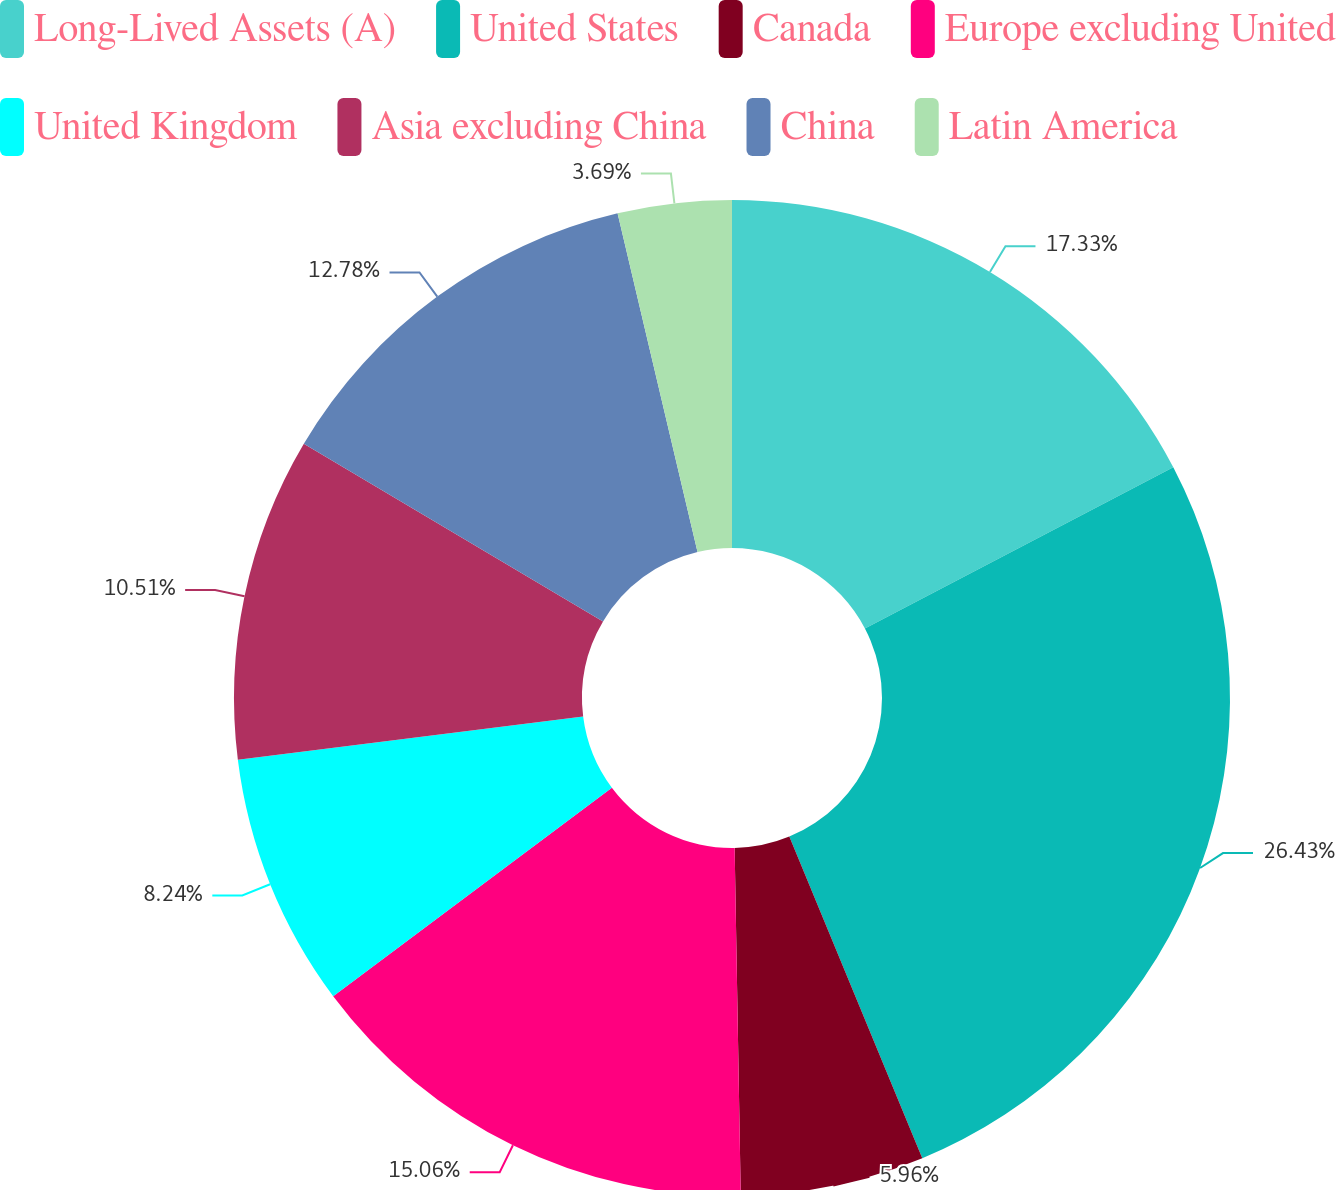<chart> <loc_0><loc_0><loc_500><loc_500><pie_chart><fcel>Long-Lived Assets (A)<fcel>United States<fcel>Canada<fcel>Europe excluding United<fcel>United Kingdom<fcel>Asia excluding China<fcel>China<fcel>Latin America<nl><fcel>17.33%<fcel>26.43%<fcel>5.96%<fcel>15.06%<fcel>8.24%<fcel>10.51%<fcel>12.78%<fcel>3.69%<nl></chart> 